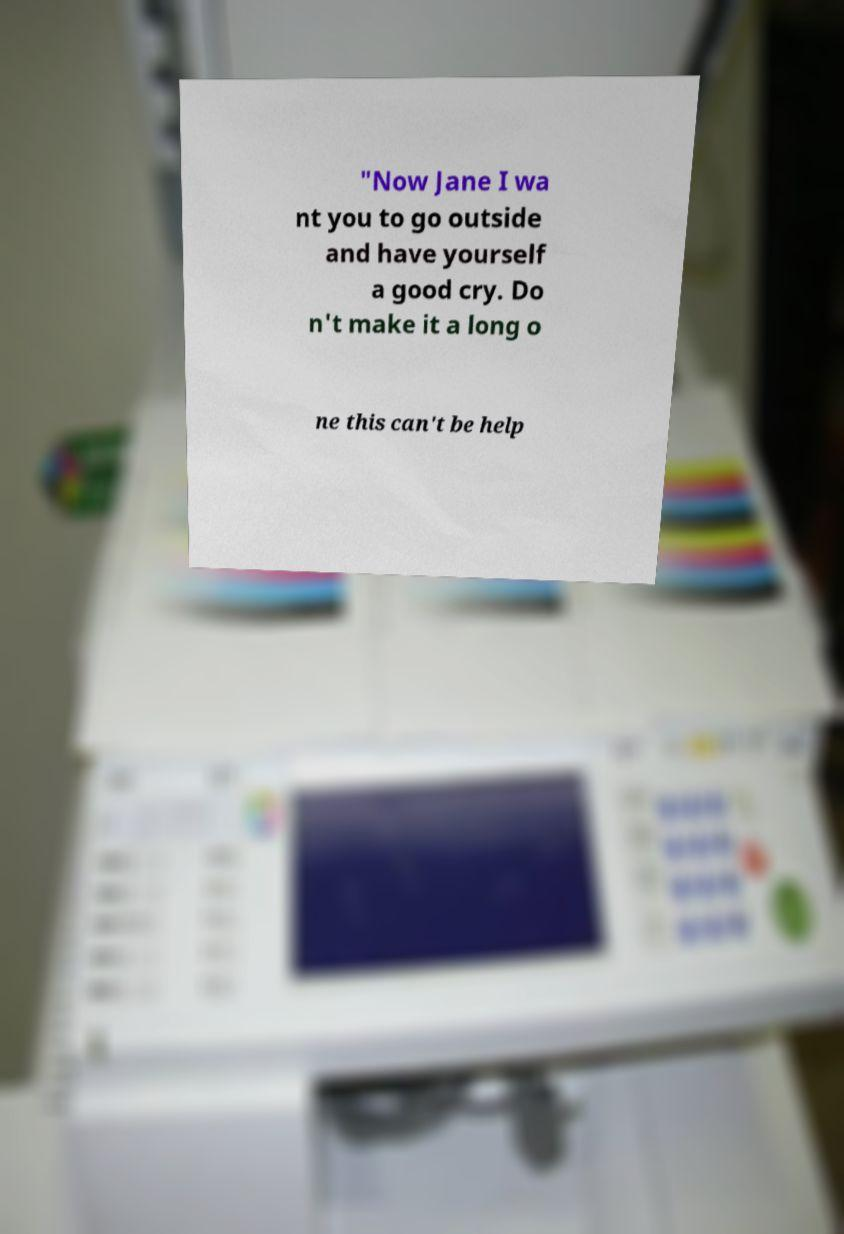Could you assist in decoding the text presented in this image and type it out clearly? "Now Jane I wa nt you to go outside and have yourself a good cry. Do n't make it a long o ne this can't be help 